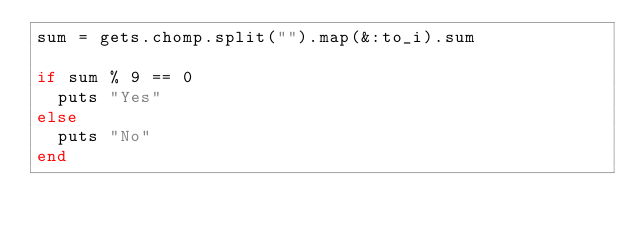Convert code to text. <code><loc_0><loc_0><loc_500><loc_500><_Ruby_>sum = gets.chomp.split("").map(&:to_i).sum

if sum % 9 == 0
  puts "Yes"
else
  puts "No"
end
</code> 